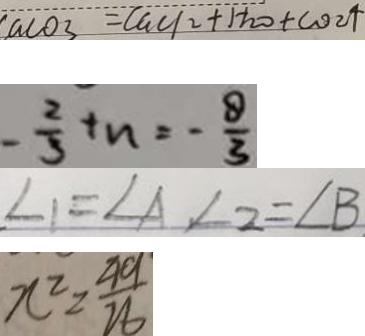<formula> <loc_0><loc_0><loc_500><loc_500>c a c o _ { 3 } = C a C l _ { 2 } + H _ { 2 } O + C O _ { 2 } \uparrow 
 - \frac { 2 } { 3 } + n = - \frac { 8 } { 3 } 
 \angle 1 = \angle A , \angle 2 = \angle B 
 x ^ { 2 } = \frac { 4 9 } { 2 6 }</formula> 